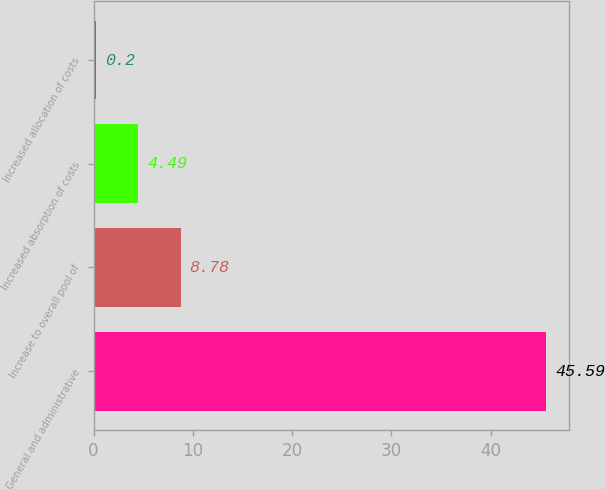<chart> <loc_0><loc_0><loc_500><loc_500><bar_chart><fcel>General and administrative<fcel>Increase to overall pool of<fcel>Increased absorption of costs<fcel>Increased allocation of costs<nl><fcel>45.59<fcel>8.78<fcel>4.49<fcel>0.2<nl></chart> 